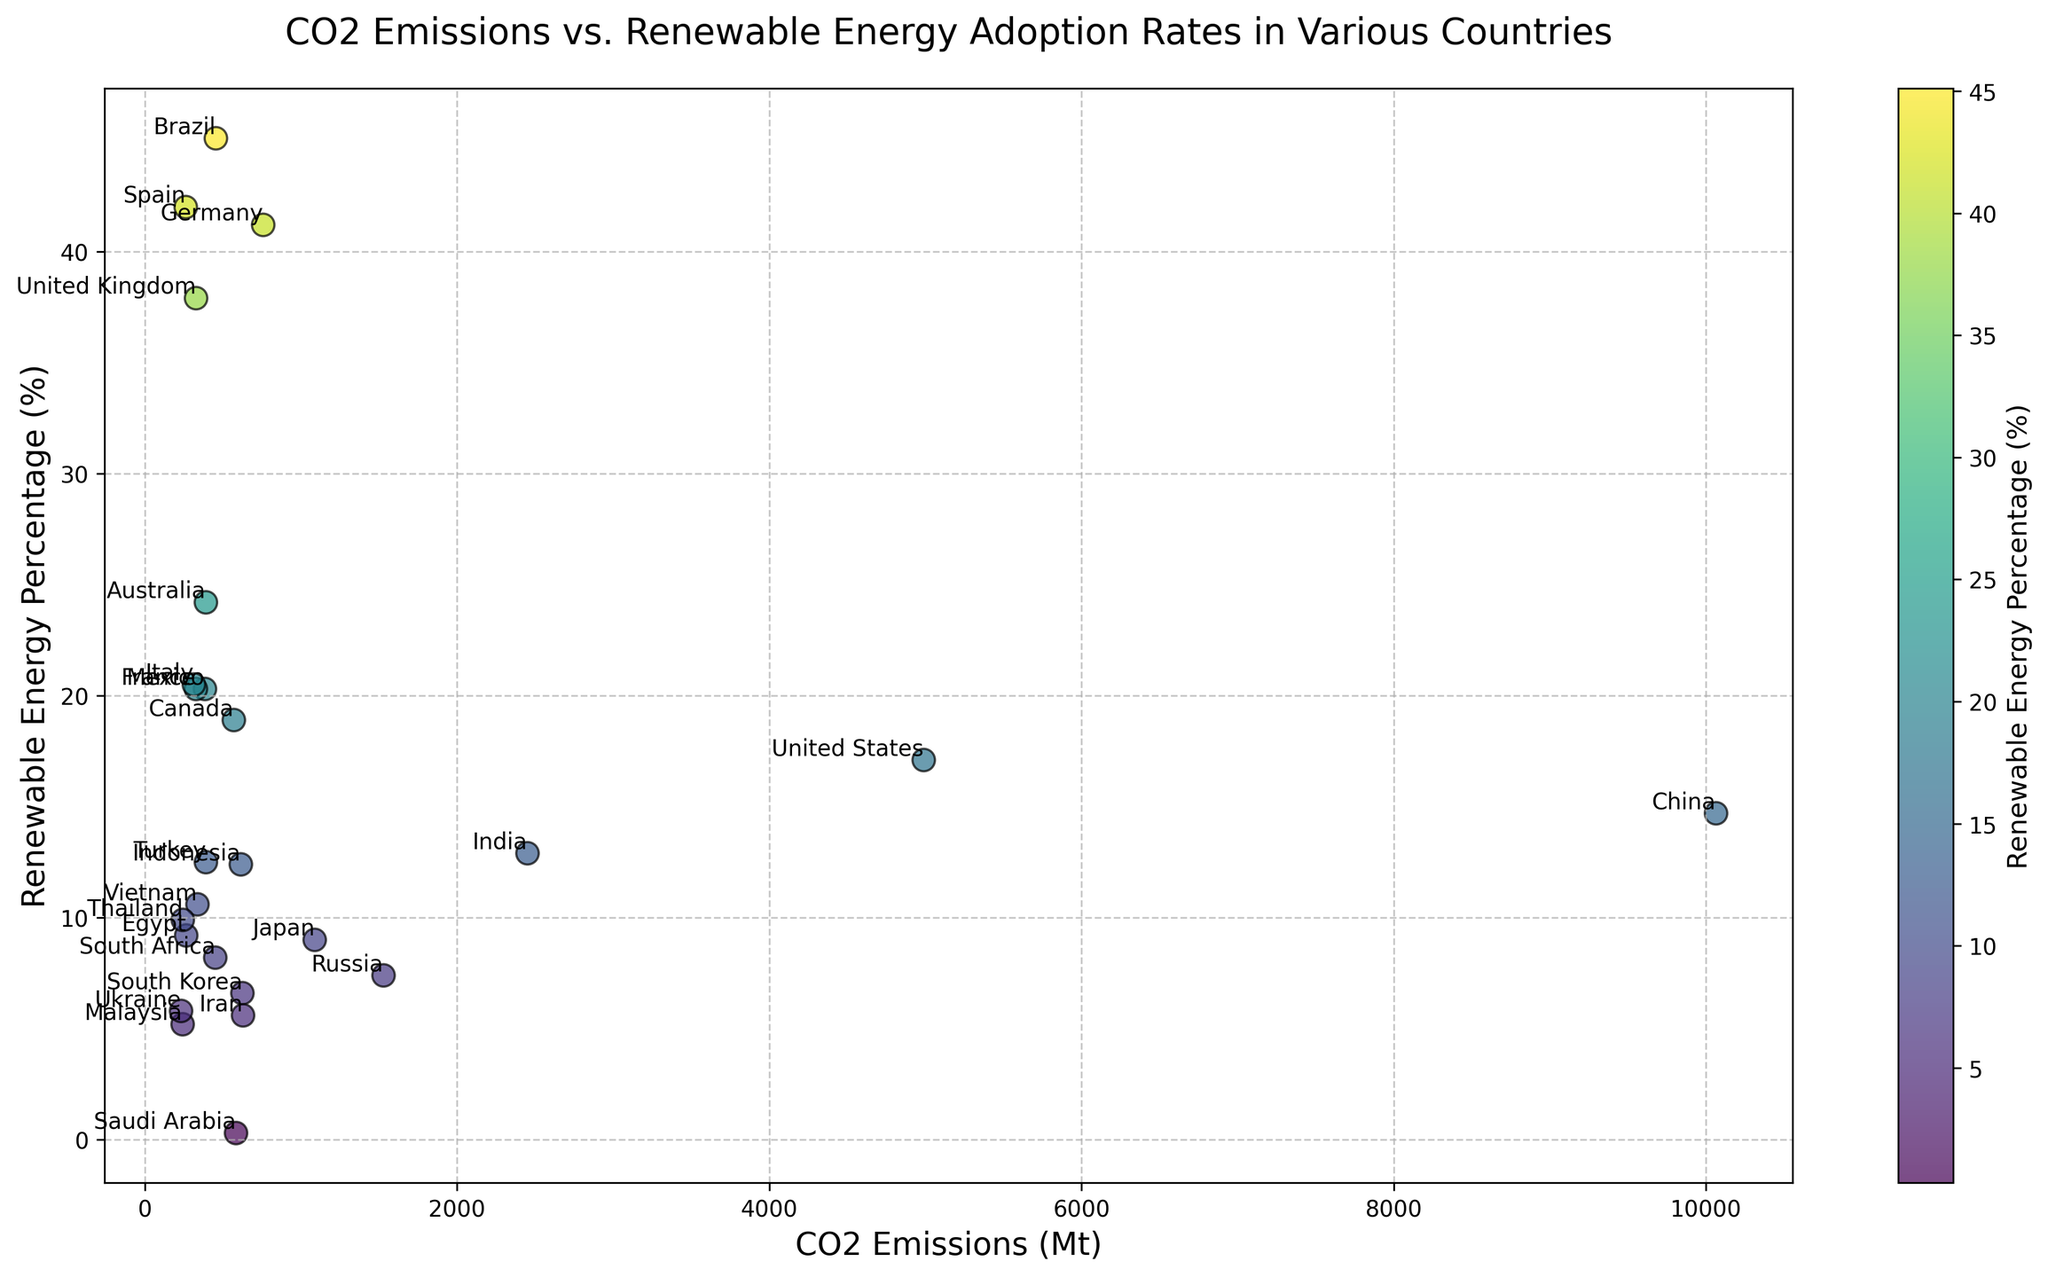Which country has the highest CO2 emissions? To determine which country has the highest CO2 emissions, look at the x-axis values, and identify the country at the farthest point to the right. That country is China.
Answer: China Which country has the highest renewable energy percentage? To identify the country with the highest renewable energy percentage, look at the y-axis values and find the highest point on the plot. That country is Brazil.
Answer: Brazil Between Germany and France, which country has higher CO2 emissions? Compare the x-axis positions of the points labeled "Germany" and "France." Germany is further to the right than France.
Answer: Germany Are there any countries with CO2 emissions greater than 5000 Mt? Check the x-axis values to see if any points are to the right of the 5000 mark. Only China exceeds 5000 Mt.
Answer: Yes, China Which two countries have the highest combined renewable energy percentage? Identify the countries with the two highest points on the y-axis. These are Brazil (45.1%) and Spain (42.0%). Adding these values gives the highest combined percentage.
Answer: Brazil and Spain Is there any country with both low CO2 emissions and low renewable energy percentage? Look for points near the origin (bottom-left) of the plot. Saudi Arabia has very low CO2 emissions (585 Mt) and a very low renewable energy percentage (0.3%).
Answer: Yes, Saudi Arabia Rank the G7 countries by their renewable energy percentage. G7 countries in the dataset are the United States, Canada, France, Germany, Italy, Japan, and the United Kingdom. Check their positions on the y-axis and sort them. Germany (41.2%), United Kingdom (37.9%), Canada (18.9%), Italy (20.5%), France (20.3%), United States (17.1%), Japan (9.0%).
Answer: Germany > United Kingdom > Italy > France > Canada > United States > Japan Which country is indicated by a point with relatively high renewable energy percentage but low CO2 emissions around 260 Mt? Find a point around 260 Mt on the x-axis and with high y-axis value. That country is Spain (263 Mt CO2 emissions, 42.0% renewable energy).
Answer: Spain What is the difference between the renewable energy percentages of Mexico and Turkey? Mexico has a renewable energy percentage of 20.3%, and Turkey has 12.5%. The difference is 20.3 - 12.5.
Answer: 7.8 Does the United Kingdom have a higher or lower CO2 emission compared to South Korea? Compare the x-axis values for points labeled "United Kingdom" and "South Korea." The United Kingdom has lower CO2 emissions (329 Mt) than South Korea (626 Mt).
Answer: Lower 